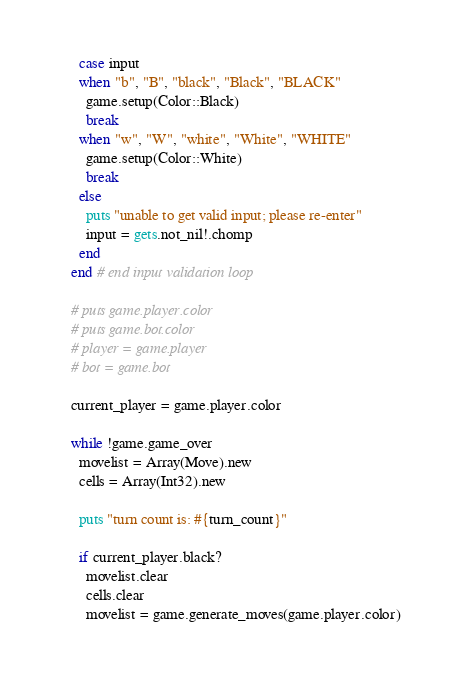<code> <loc_0><loc_0><loc_500><loc_500><_Crystal_>      case input
      when "b", "B", "black", "Black", "BLACK"
        game.setup(Color::Black)
        break
      when "w", "W", "white", "White", "WHITE"
        game.setup(Color::White)
        break
      else
        puts "unable to get valid input; please re-enter"
        input = gets.not_nil!.chomp
      end
    end # end input validation loop

    # puts game.player.color
    # puts game.bot.color
    # player = game.player
    # bot = game.bot

    current_player = game.player.color

    while !game.game_over
      movelist = Array(Move).new
      cells = Array(Int32).new

      puts "turn count is: #{turn_count}"

      if current_player.black?
        movelist.clear
        cells.clear
        movelist = game.generate_moves(game.player.color)
</code> 